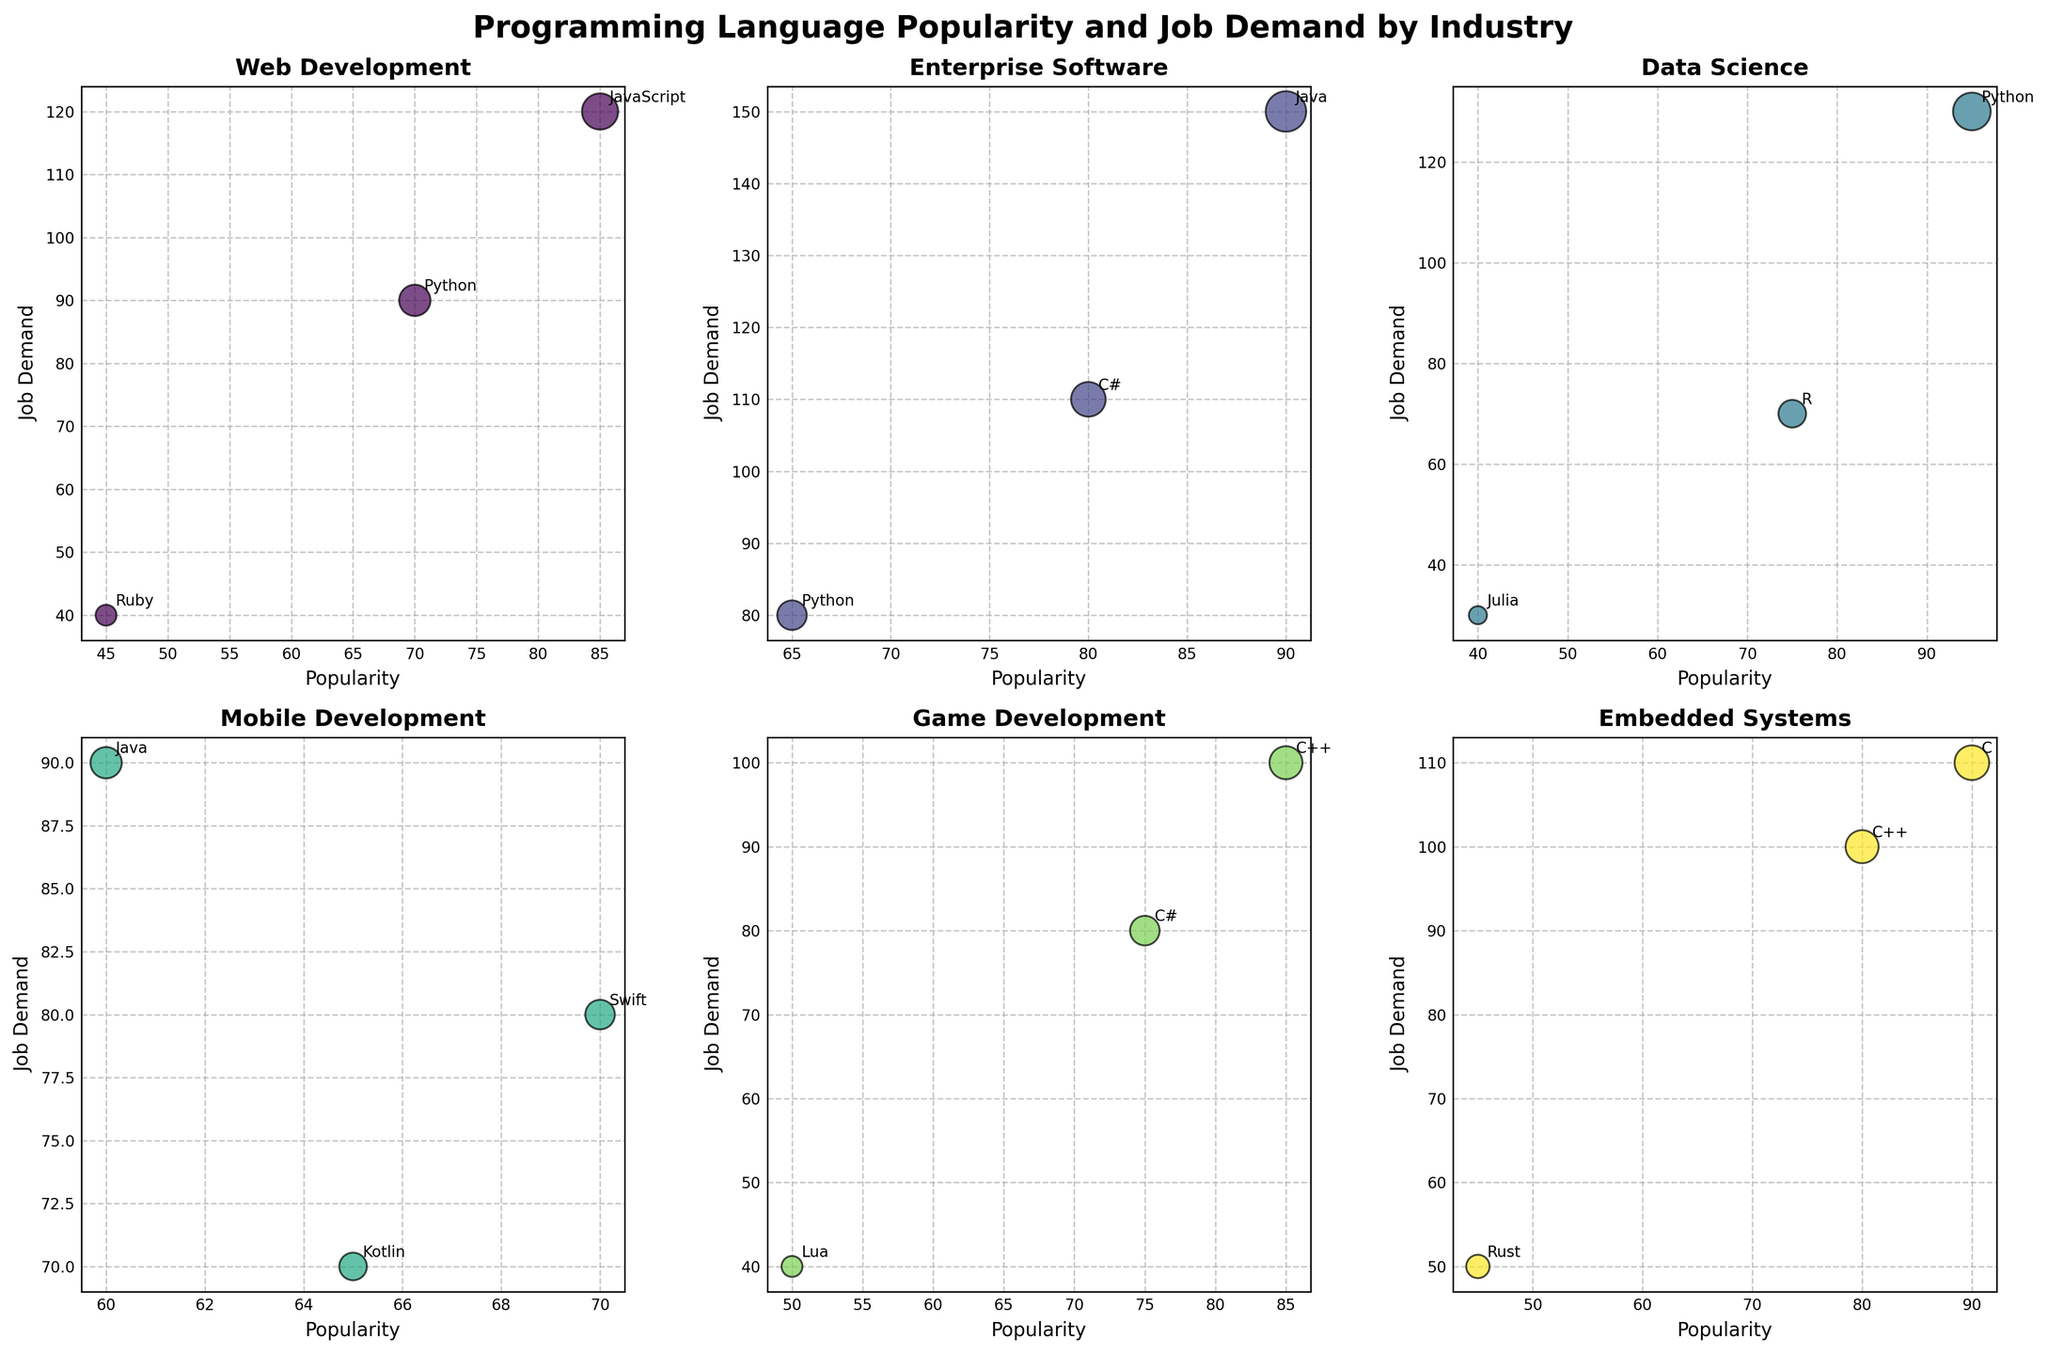What is the title of the figure? The title of the figure is written on the top and is big and bold, making it easily noticeable. The title gives an overview of the content in the figure.
Answer: Programming Language Popularity and Job Demand by Industry How many industries are shown in the subplot? The figure is divided into subplots, each representing a different industry. By counting the individual subplots, we can determine the number of industries shown.
Answer: 6 Which industry has the highest job demand for any programming language and what is the language? By looking at the 'job demand' axis and identifying the highest point, then checking the corresponding language label helps determine the answer.
Answer: Enterprise Software, Java Which language has the smallest bubble in Data Science? Bubbles represent job demand, so the smallest bubble corresponds to the least job demand. Look at the Data Science subplot and identify the smallest bubble with its label.
Answer: Julia In Web Development, what is the difference in job demand between JavaScript and Ruby? Identify the job demands for JavaScript and Ruby in the Web Development subplot by looking at the y-axis. Calculate the difference in these values.
Answer: 80 Which industry shows the use of Lua, and what is the job demand for it? Check each subplot for the label 'Lua' to find its industry and job demand value on the y-axis.
Answer: Game Development, 40 Compare the popularity of Python in Web Development and Data Science. Which has higher popularity? Locate Python in both the Web Development and Data Science subplots, then compare the values on the x-axis for 'popularity'.
Answer: Data Science For the Embedded Systems industry, which two languages have the closest job demand? Review the Embedded Systems subplot and identify which two bubbles have the closest positions on the y-axis.
Answer: C++ and C What's the total job demand for the Mobile Development industry? Add the job demand values for all languages in the Mobile Development subplot by summing the respective y-values.
Answer: 240 In the Enterprise Software industry, which language has higher popularity: C# or Python? Locate C# and Python in the Enterprise Software subplot, then compare their positions on the x-axis for 'popularity'.
Answer: C# 